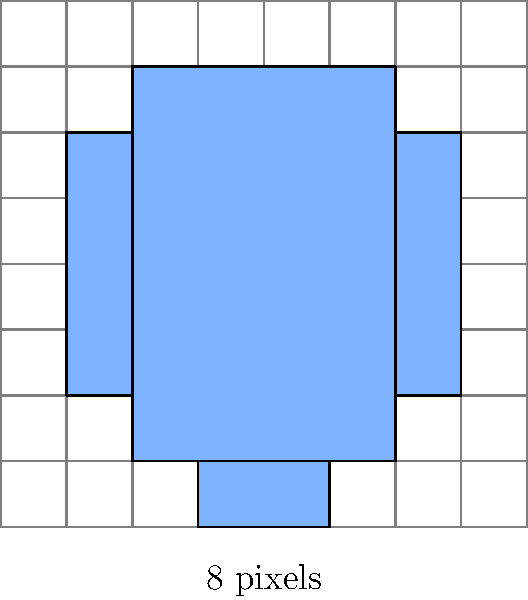In the 8-bit character sprite shown above, what is the total number of pixels used to create the character, including both filled and empty pixels? To calculate the total number of pixels in the 8-bit character sprite, we need to follow these steps:

1. Identify the dimensions of the sprite:
   The sprite is contained within an 8x8 grid.

2. Calculate the total number of pixels:
   $\text{Total pixels} = \text{Width} \times \text{Height}$
   $\text{Total pixels} = 8 \times 8 = 64$

3. Note that this includes both filled and empty pixels:
   - Filled pixels form the character's shape
   - Empty pixels are part of the transparent background

4. In 8-bit sprite design, every pixel in the grid is considered part of the sprite, regardless of whether it's filled or empty, as this affects the overall design and hitbox of the character in the game.

Therefore, the total number of pixels used to create this 8-bit character sprite is 64.
Answer: 64 pixels 